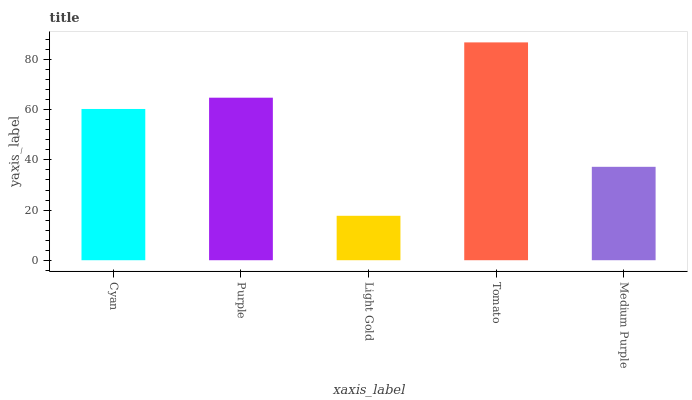Is Light Gold the minimum?
Answer yes or no. Yes. Is Tomato the maximum?
Answer yes or no. Yes. Is Purple the minimum?
Answer yes or no. No. Is Purple the maximum?
Answer yes or no. No. Is Purple greater than Cyan?
Answer yes or no. Yes. Is Cyan less than Purple?
Answer yes or no. Yes. Is Cyan greater than Purple?
Answer yes or no. No. Is Purple less than Cyan?
Answer yes or no. No. Is Cyan the high median?
Answer yes or no. Yes. Is Cyan the low median?
Answer yes or no. Yes. Is Purple the high median?
Answer yes or no. No. Is Medium Purple the low median?
Answer yes or no. No. 